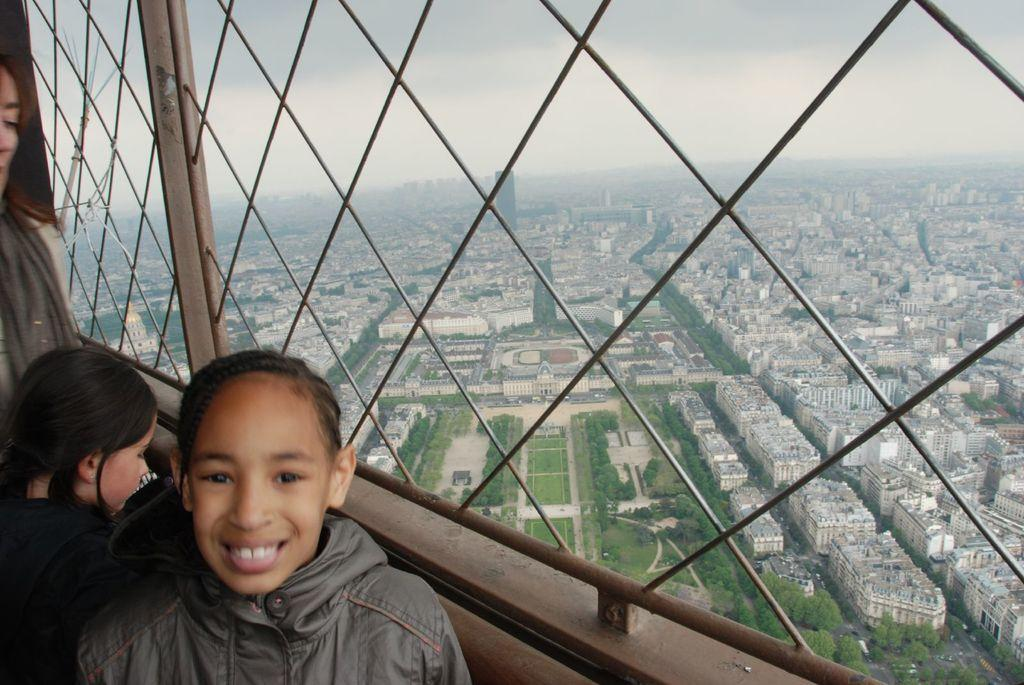Who or what can be seen in the image? There are people in the image. What structures are present in the image? There are buildings in the image. What type of natural elements are visible in the image? There are trees in the image. What is visible in the background of the image? The sky is visible in the image. What type of transportation can be seen in the image? There are vehicles on the road in the image. Where are the toys and waste located in the image? There are no toys or waste present in the image. 